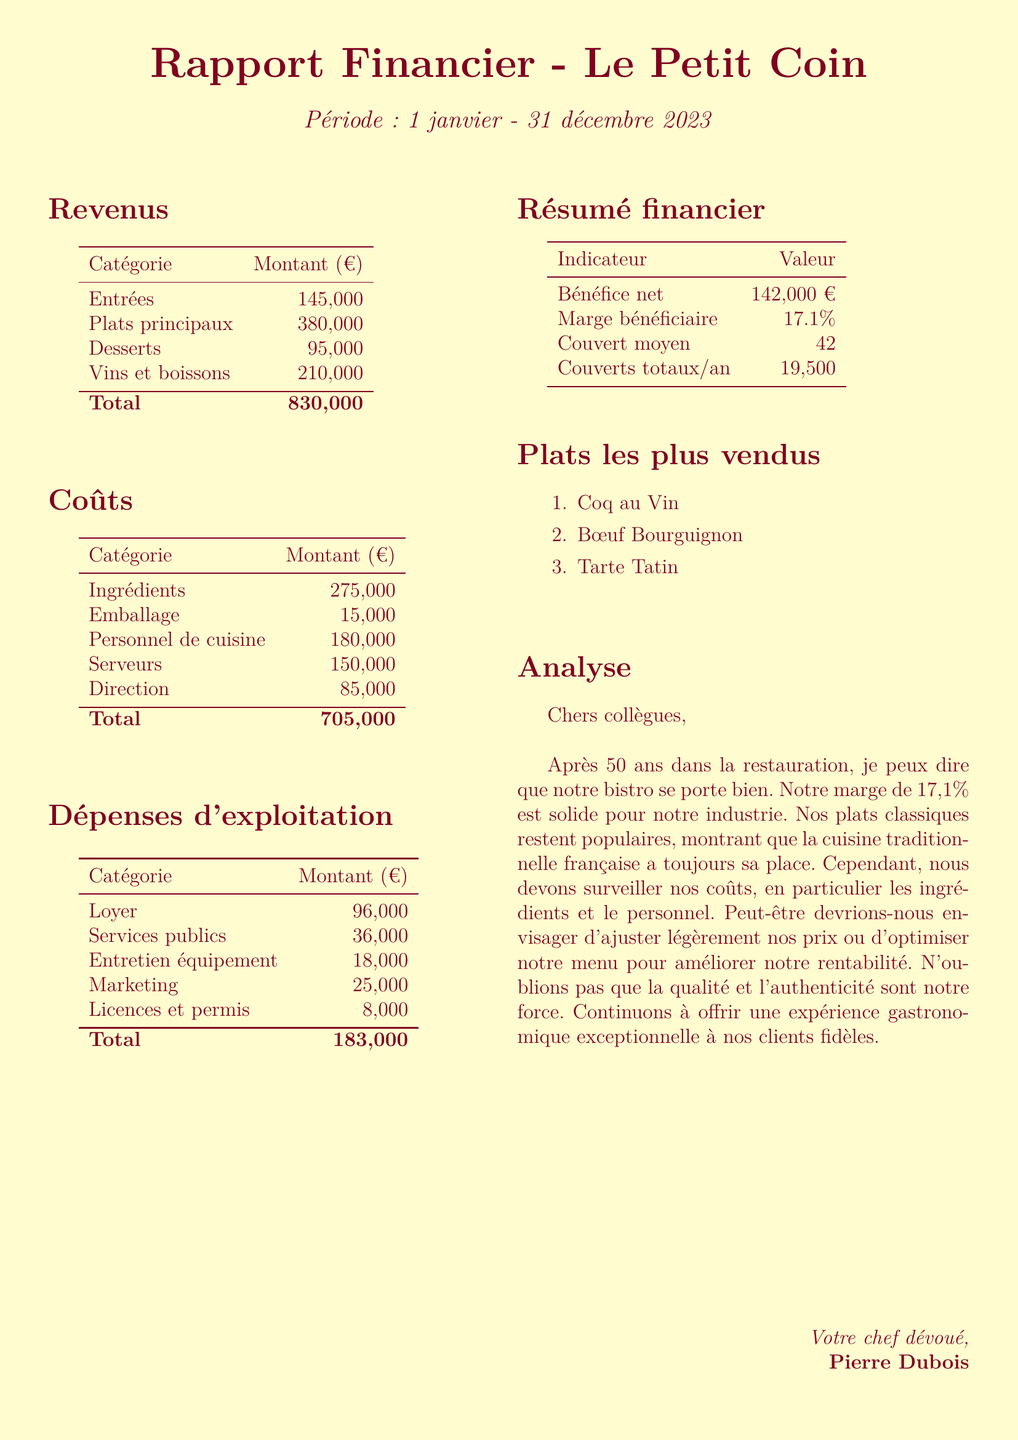What is the bistro's name? The name of the bistro is provided at the beginning of the document.
Answer: Le Petit Coin What is the reporting period? The reporting period is specified at the start of the document.
Answer: January 1 - December 31, 2023 What is the total revenue? The total revenue is the sum of all revenue categories listed in the document: 145000 + 380000 + 95000 + 210000.
Answer: 830000 What is the net profit? The net profit is explicitly stated in the financial summary section of the document.
Answer: 142000 How much was spent on ingredients? The amount spent on ingredients is clearly listed under food costs in the document.
Answer: 275000 What is the profit margin? The profit margin is mentioned in the summary financial indicators section of the document.
Answer: 17.1% How many total covers were there in the year? The total covers per year is provided in the summary of financial indicators.
Answer: 19500 What is the cost of rent? The cost of rent is one of the operating expenses detailed in the document.
Answer: 96000 Which dish is the best-seller? The best-selling dishes are listed in the document, with the first one being the most popular.
Answer: Coq au Vin 